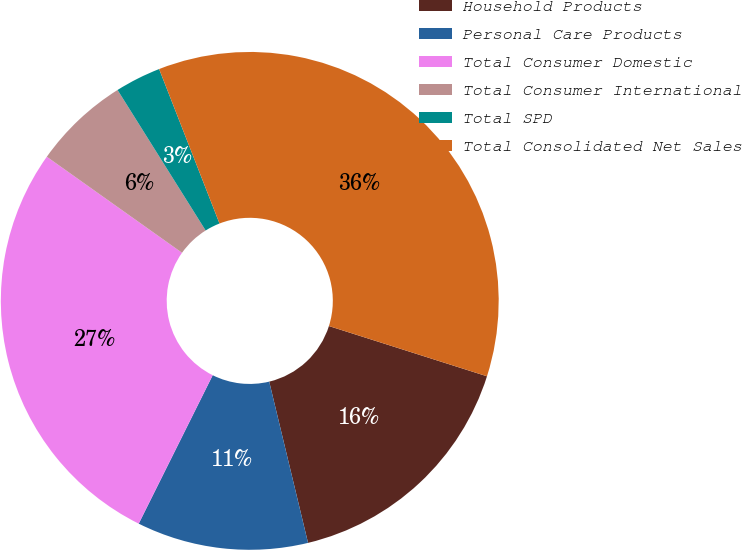Convert chart. <chart><loc_0><loc_0><loc_500><loc_500><pie_chart><fcel>Household Products<fcel>Personal Care Products<fcel>Total Consumer Domestic<fcel>Total Consumer International<fcel>Total SPD<fcel>Total Consolidated Net Sales<nl><fcel>16.34%<fcel>11.12%<fcel>27.47%<fcel>6.26%<fcel>2.98%<fcel>35.83%<nl></chart> 